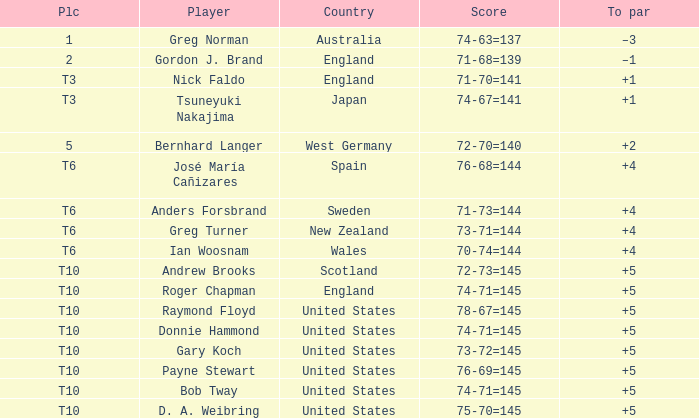What was Anders Forsbrand's score when the TO par is +4? 71-73=144. Give me the full table as a dictionary. {'header': ['Plc', 'Player', 'Country', 'Score', 'To par'], 'rows': [['1', 'Greg Norman', 'Australia', '74-63=137', '–3'], ['2', 'Gordon J. Brand', 'England', '71-68=139', '–1'], ['T3', 'Nick Faldo', 'England', '71-70=141', '+1'], ['T3', 'Tsuneyuki Nakajima', 'Japan', '74-67=141', '+1'], ['5', 'Bernhard Langer', 'West Germany', '72-70=140', '+2'], ['T6', 'José María Cañizares', 'Spain', '76-68=144', '+4'], ['T6', 'Anders Forsbrand', 'Sweden', '71-73=144', '+4'], ['T6', 'Greg Turner', 'New Zealand', '73-71=144', '+4'], ['T6', 'Ian Woosnam', 'Wales', '70-74=144', '+4'], ['T10', 'Andrew Brooks', 'Scotland', '72-73=145', '+5'], ['T10', 'Roger Chapman', 'England', '74-71=145', '+5'], ['T10', 'Raymond Floyd', 'United States', '78-67=145', '+5'], ['T10', 'Donnie Hammond', 'United States', '74-71=145', '+5'], ['T10', 'Gary Koch', 'United States', '73-72=145', '+5'], ['T10', 'Payne Stewart', 'United States', '76-69=145', '+5'], ['T10', 'Bob Tway', 'United States', '74-71=145', '+5'], ['T10', 'D. A. Weibring', 'United States', '75-70=145', '+5']]} 